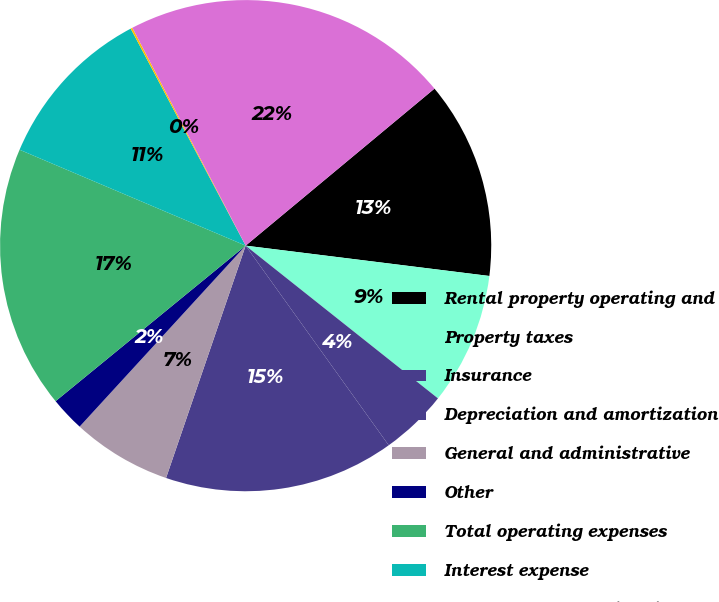<chart> <loc_0><loc_0><loc_500><loc_500><pie_chart><fcel>Rental property operating and<fcel>Property taxes<fcel>Insurance<fcel>Depreciation and amortization<fcel>General and administrative<fcel>Other<fcel>Total operating expenses<fcel>Interest expense<fcel>Loss from early extinguishment<fcel>Total expenses<nl><fcel>13.01%<fcel>8.71%<fcel>4.42%<fcel>15.15%<fcel>6.56%<fcel>2.27%<fcel>17.3%<fcel>10.86%<fcel>0.12%<fcel>21.59%<nl></chart> 